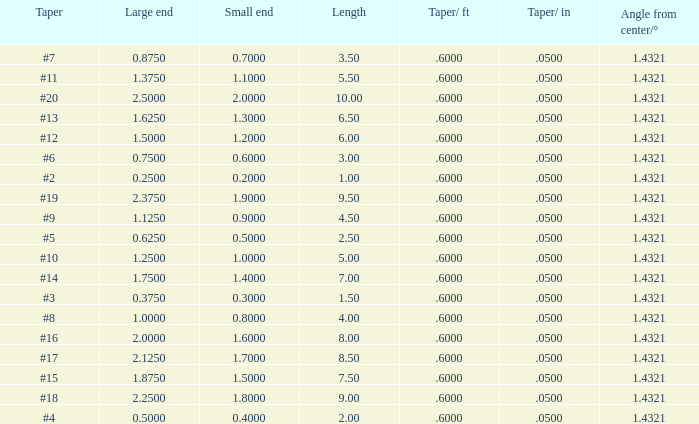Which Length has a Taper of #15, and a Large end larger than 1.875? None. 